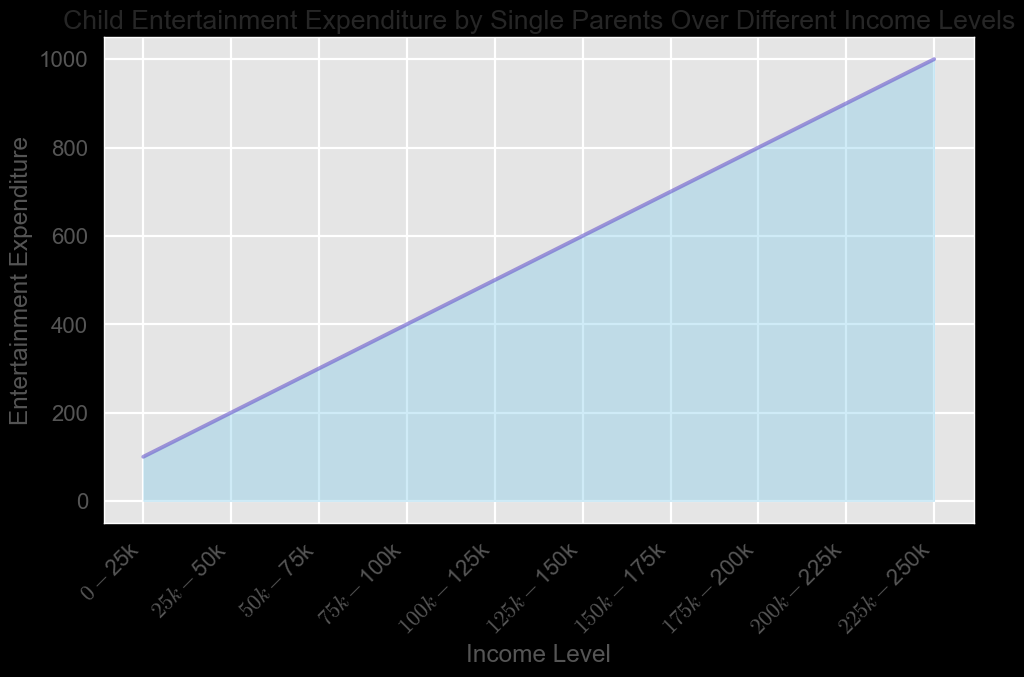What's the highest entertainment expenditure in the chart? The chart shows the highest entertainment expenditure is at the $225k-$250k income level, with the value at 1000.
Answer: 1000 How does the entertainment expenditure change as income increases? As income level increases from $0-$25k to $225k-$250k, the entertainment expenditure consistently increases in a linear manner.
Answer: It increases What is the difference in entertainment expenditure between the $75k-$100k and $150k-$175k income levels? From the chart, the entertainment expenditure for the $75k-$100k income level is 400 and for the $150k-$175k income level is 700. The difference is 700 - 400 = 300.
Answer: 300 Which income level shows an expenditure exactly halfway between the lowest and the highest expenditure values on the chart? The lowest expenditure is 100, and the highest is 1000. Halfway would be (1000 - 100) / 2 + 100 = 550. According to the chart, the $125k-$150k income level shows an expenditure of 600, which is closest to 550.
Answer: $125k-$150k How many income levels exhibit an entertainment expenditure of 500 or more? The chart shows that entertainment expenditure exceeds 500 starting from the $100k-$125k income level up to the $225k-$250k level, totaling 6 different income levels.
Answer: 6 Which two consecutive income levels have the smallest increase in entertainment expenditure? The smallest increase occurs between the $150k-$175k and $175k-$200k income levels, with an increase from 700 to 800, a difference of only 100.
Answer: $150k-$175k and $175k-$200k Describe the visual pattern of the chart. The chart shows a steady gradient increase in the area fill color from the left to the right, with the y-axis indicating that the expenditure grows proportionately with income levels.
Answer: steady gradient increase What is the average entertainment expenditure across all the income levels shown in the chart? Sum all the expenditures: 100, 200, 300, 400, 500, 600, 700, 800, 900, 1000 = 5500. Divide by the number of income levels, which is 10. So, 5500 / 10 = 550.
Answer: 550 